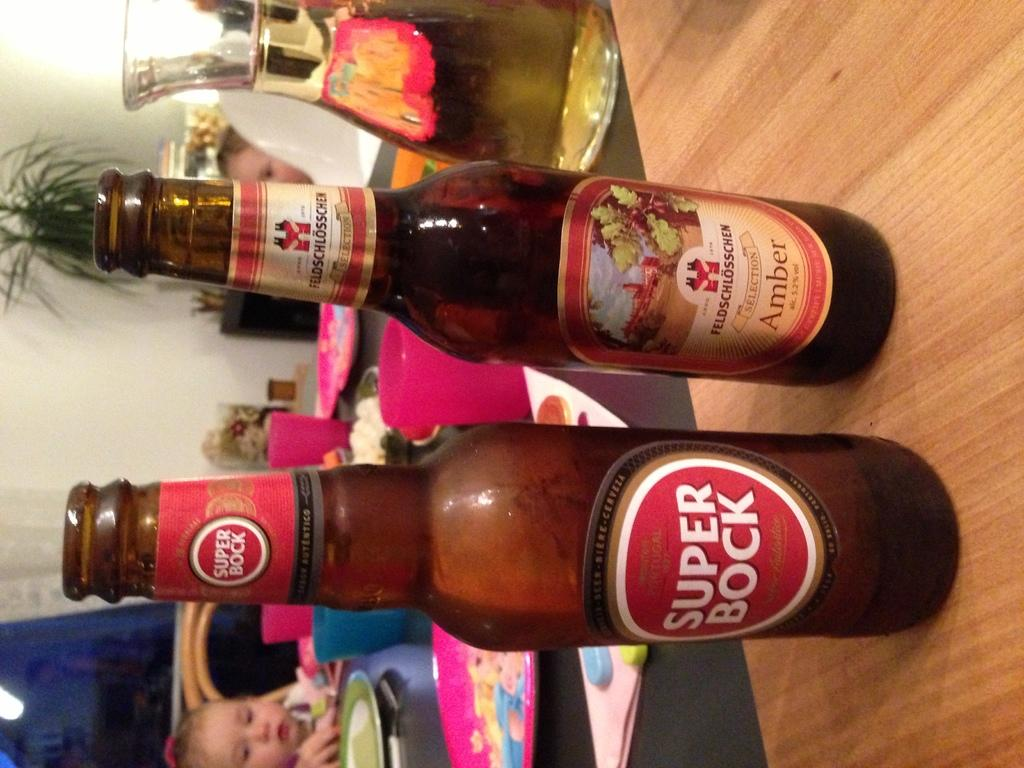<image>
Offer a succinct explanation of the picture presented. Bottle of amber and a bottle of super bock sitting on a table 